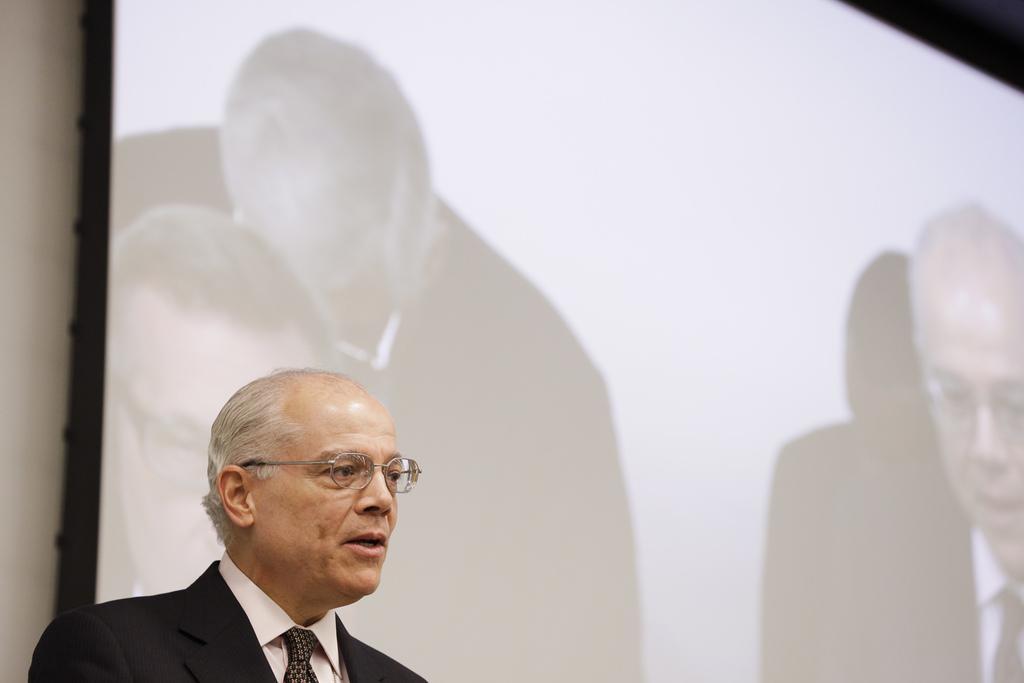Please provide a concise description of this image. On the left side of this image there is a man wearing a black color suit, facing towards the right side. It seems like he is speaking. At the back of this man there is a screen which is attached to the wall. On the screen, I can see the images of persons. 